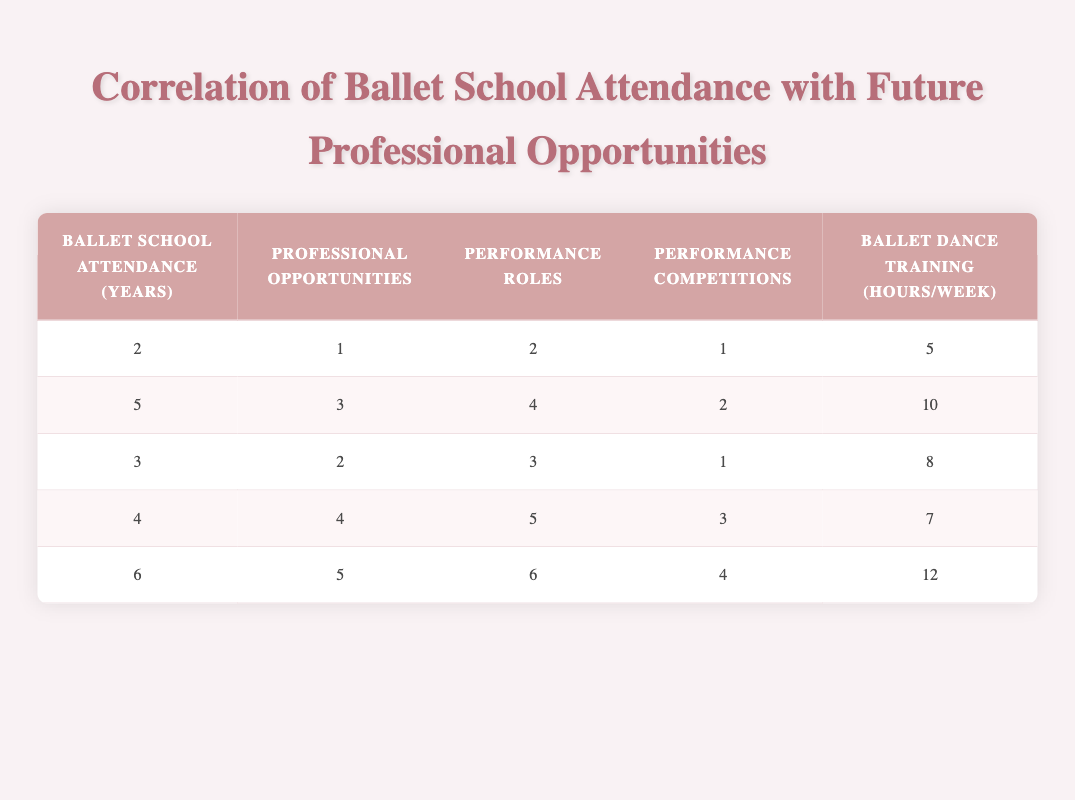What is the professional opportunity rating for someone who attended ballet school for 5 years? According to the table, the row corresponding to 5 years of ballet school attendance shows a professional opportunities rating of 3.
Answer: 3 How many performance roles does a student with 4 years of ballet school attendance have? The data for 4 years of ballet school attendance indicates that the student has 5 performance roles.
Answer: 5 What is the average number of ballet dance training hours per week across all five data points? The sum of ballet dance training hours per week is 5 + 10 + 8 + 7 + 12 = 42. There are 5 data points, so the average is 42/5 = 8.4.
Answer: 8.4 Is it true that students who attended ballet school for 2 years have more performance competitions than those with 3 years of attendance? Students with 2 years of attendance have 1 performance competition while those with 3 years have 1 as well; thus, it is false that the 2-year attendees have more.
Answer: No If a student attended ballet school for 6 years, how does their professional opportunities rating compare to the average rating for all students? The professional opportunities rating for 6 years is 5. The average for all students is (1 + 3 + 2 + 4 + 5)/5 = 3. The 6-year student's rating of 5 is higher than the average of 3.
Answer: Higher than average 